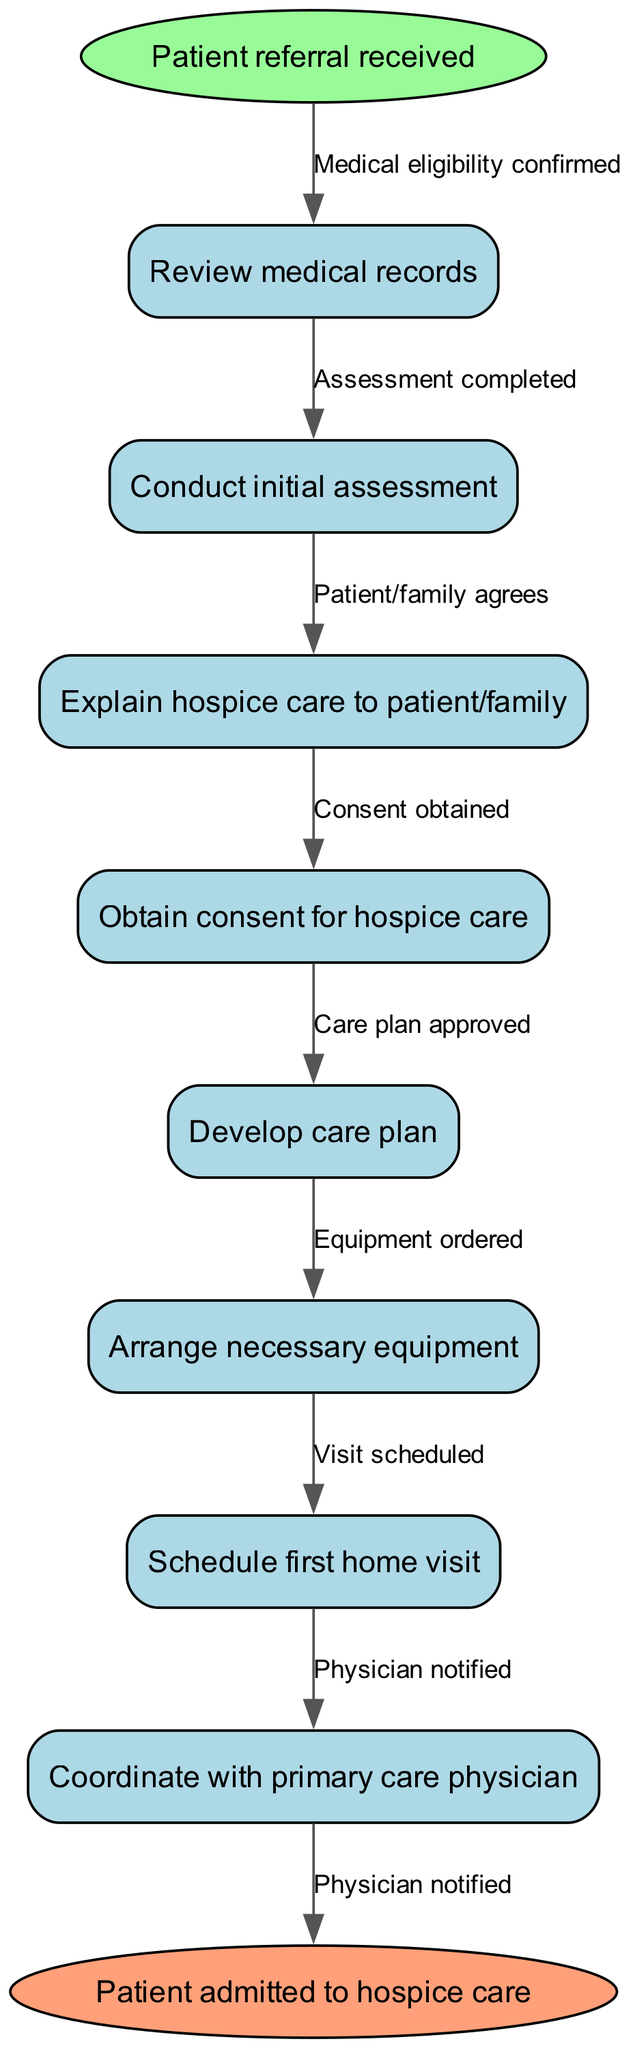What is the first step in the patient admission process? The diagram indicates that the first step is the node labeled "Patient referral received." It is the starting point of the process flowchart.
Answer: Patient referral received How many nodes are present in the diagram? The diagram contains a total of eight nodes: one start node, six process nodes, and one end node. Counting these gives a total of eight.
Answer: 8 What is the last node in the process? The last node in the diagram is labeled "Patient admitted to hospice care," which signifies the completion of the admission process.
Answer: Patient admitted to hospice care What relationship connects the "Review medical records" node to the "Conduct initial assessment" node? In the flowchart, the edge connecting the "Review medical records" node to the "Conduct initial assessment" node is labeled "Medical eligibility confirmed," indicating that this is the condition needed to proceed to the next step.
Answer: Medical eligibility confirmed What is the number of edges in the diagram? The flowchart has a total of seven edges that connect the nodes, as there are six transitions between the process nodes and one from the start to the first process node.
Answer: 7 What is required after conducting the initial assessment? After the "Conduct initial assessment" node, the next step, according to the flowchart, is to "Explain hospice care to patient/family." This indicates the next action in the process.
Answer: Explain hospice care to patient/family Which node requires obtaining consent? The diagram shows that the "Obtain consent for hospice care" node is a necessary step after explaining hospice care to the patient and family, indicating that consent is needed before proceeding.
Answer: Obtain consent for hospice care Who is notified at the end of the process? The final edge in the flowchart indicates that "Physician notified" is the final action taken which signifies communication back to the physician regarding the admission process.
Answer: Physician notified 